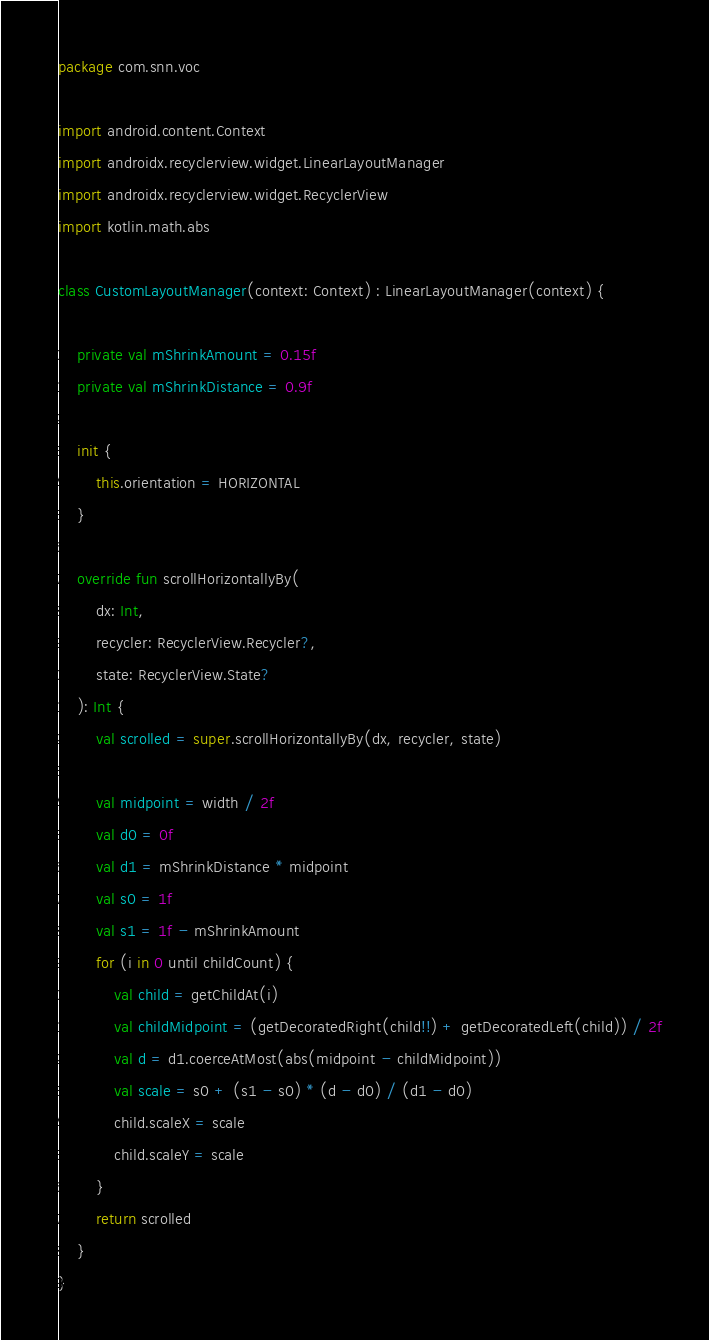Convert code to text. <code><loc_0><loc_0><loc_500><loc_500><_Kotlin_>package com.snn.voc

import android.content.Context
import androidx.recyclerview.widget.LinearLayoutManager
import androidx.recyclerview.widget.RecyclerView
import kotlin.math.abs

class CustomLayoutManager(context: Context) : LinearLayoutManager(context) {

    private val mShrinkAmount = 0.15f
    private val mShrinkDistance = 0.9f

    init {
        this.orientation = HORIZONTAL
    }

    override fun scrollHorizontallyBy(
        dx: Int,
        recycler: RecyclerView.Recycler?,
        state: RecyclerView.State?
    ): Int {
        val scrolled = super.scrollHorizontallyBy(dx, recycler, state)

        val midpoint = width / 2f
        val d0 = 0f
        val d1 = mShrinkDistance * midpoint
        val s0 = 1f
        val s1 = 1f - mShrinkAmount
        for (i in 0 until childCount) {
            val child = getChildAt(i)
            val childMidpoint = (getDecoratedRight(child!!) + getDecoratedLeft(child)) / 2f
            val d = d1.coerceAtMost(abs(midpoint - childMidpoint))
            val scale = s0 + (s1 - s0) * (d - d0) / (d1 - d0)
            child.scaleX = scale
            child.scaleY = scale
        }
        return scrolled
    }
}</code> 